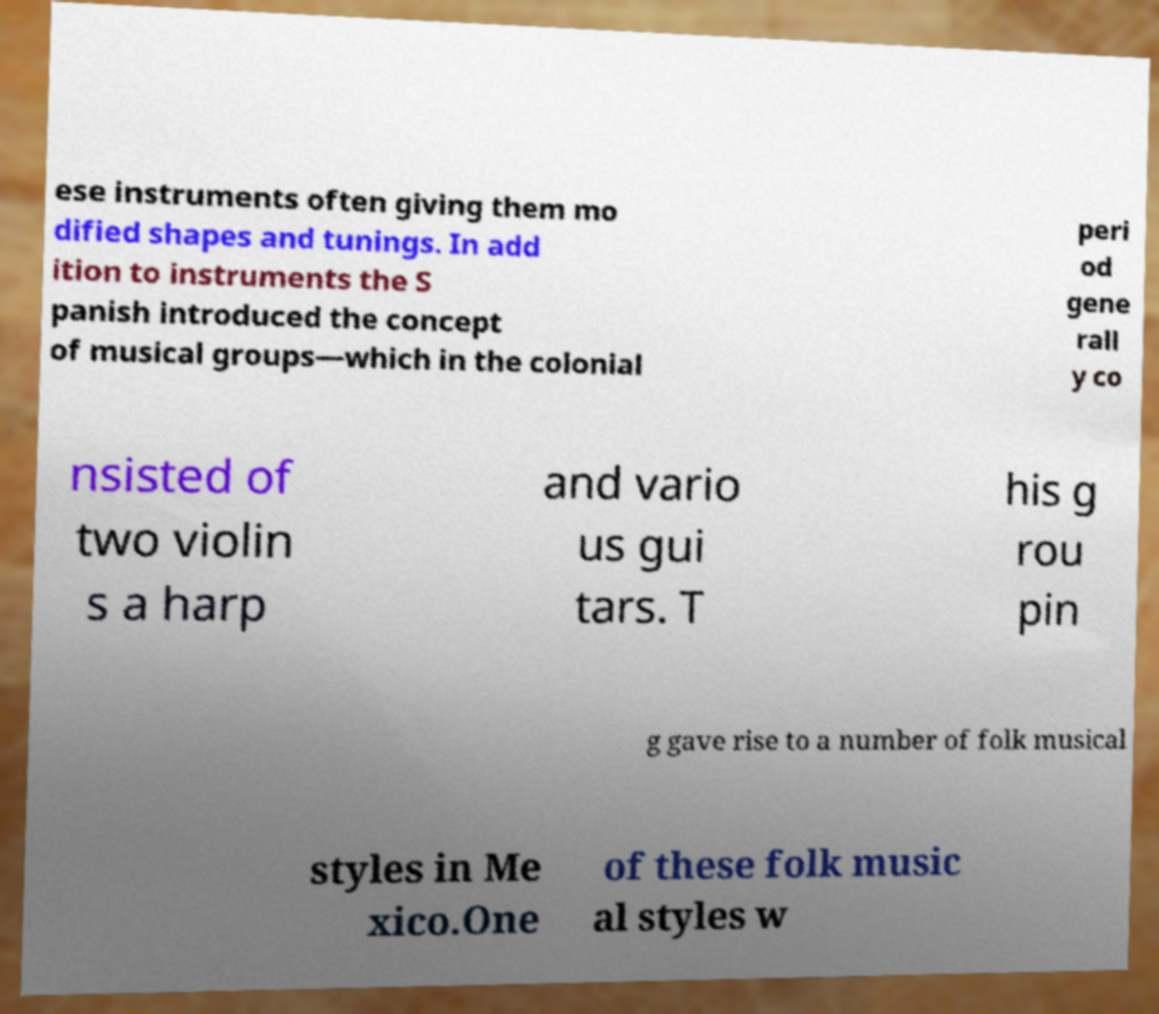Can you read and provide the text displayed in the image?This photo seems to have some interesting text. Can you extract and type it out for me? ese instruments often giving them mo dified shapes and tunings. In add ition to instruments the S panish introduced the concept of musical groups—which in the colonial peri od gene rall y co nsisted of two violin s a harp and vario us gui tars. T his g rou pin g gave rise to a number of folk musical styles in Me xico.One of these folk music al styles w 